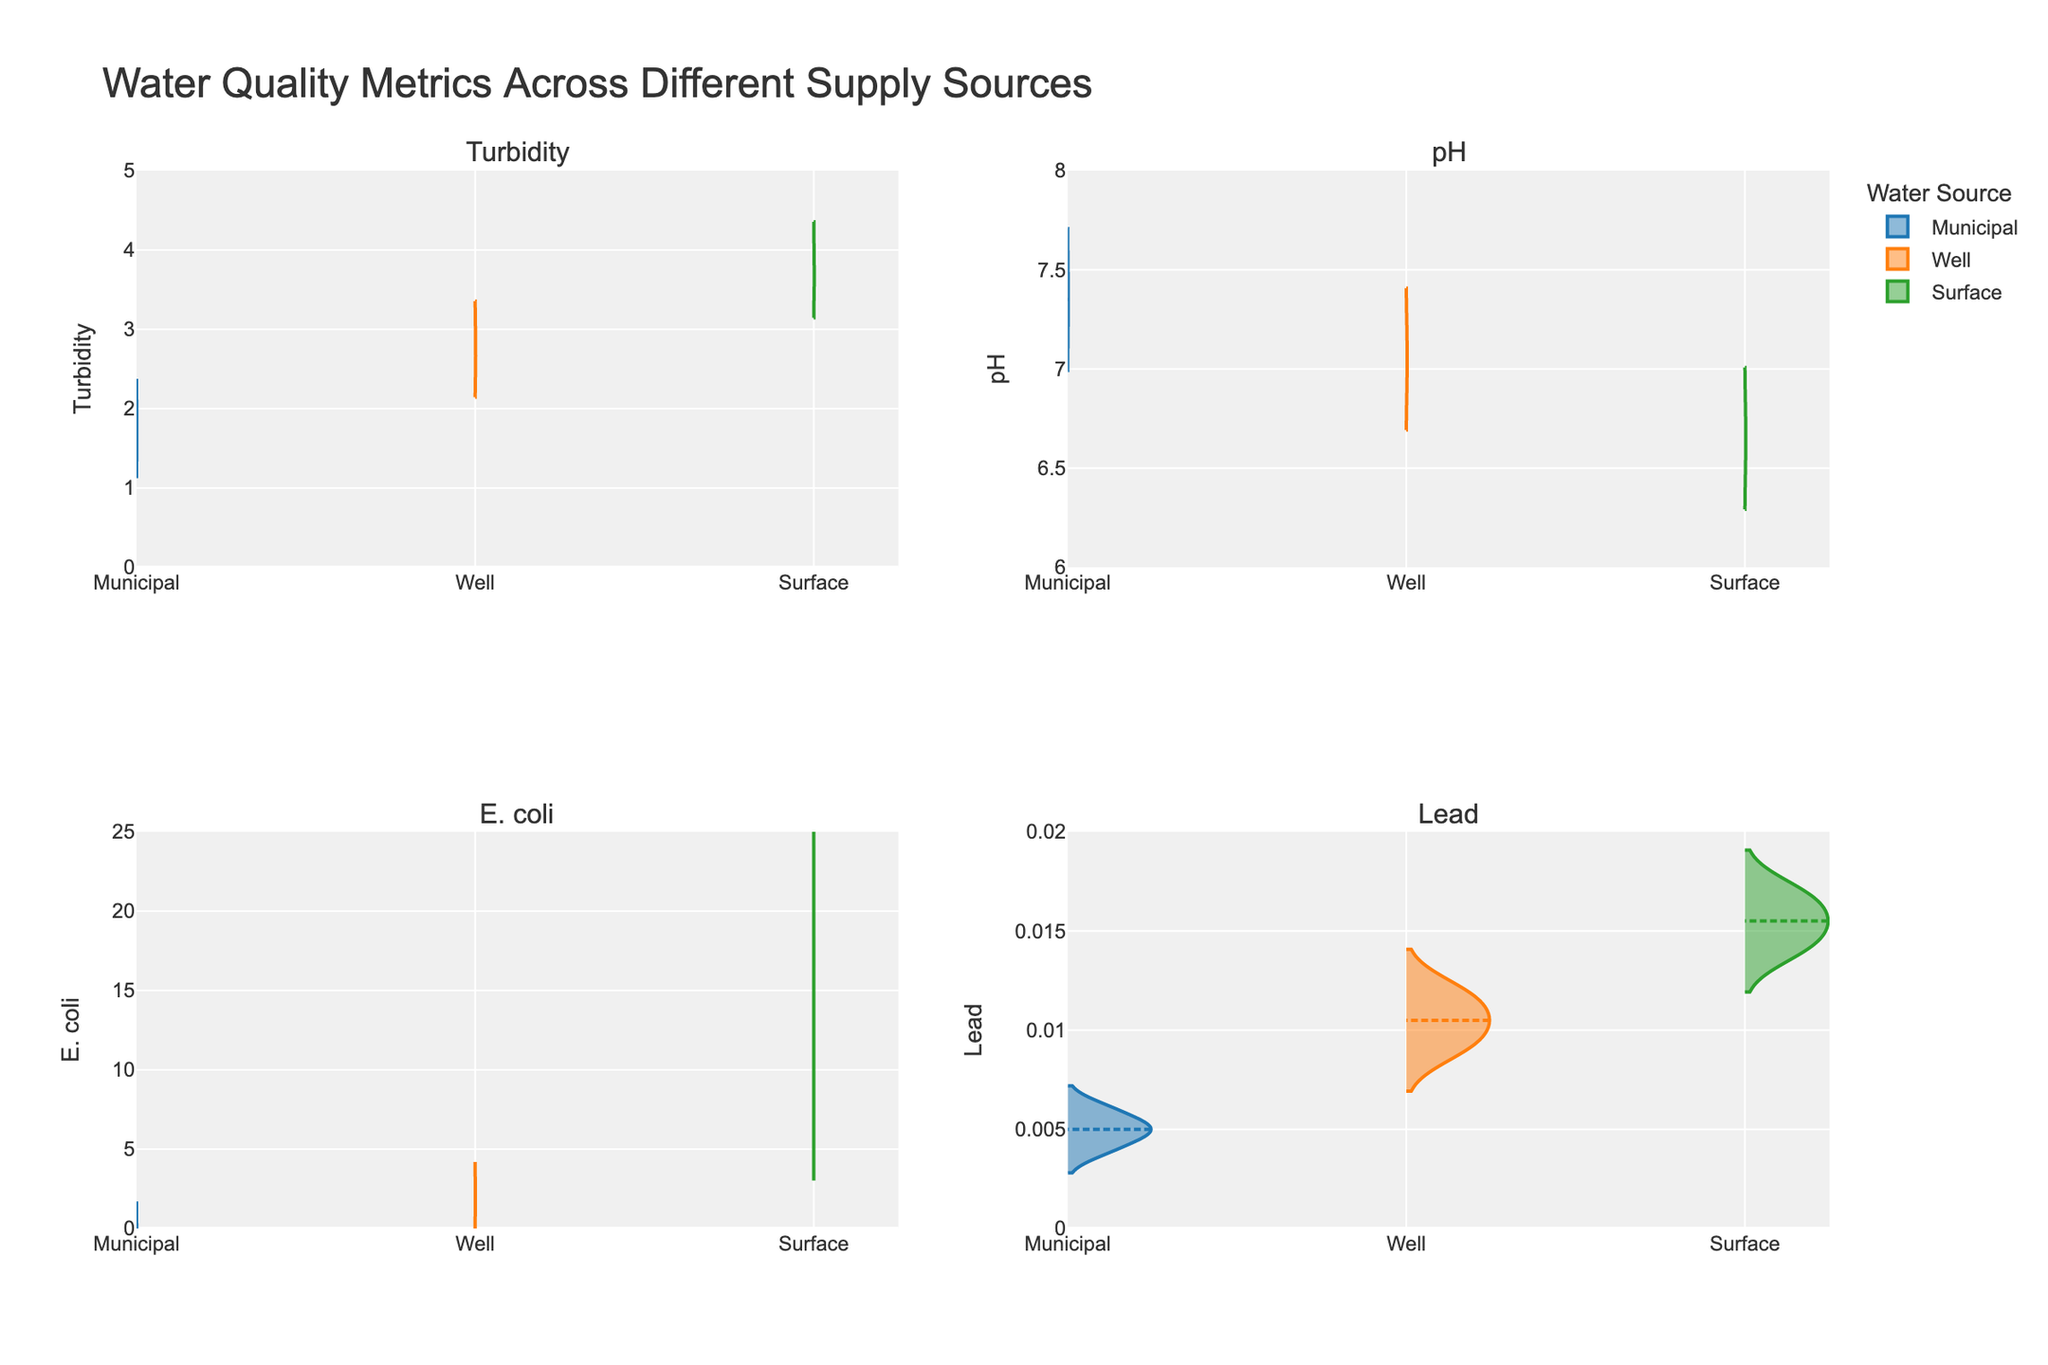What is the median turbidity value for the Municipal water source? Look at the violin plot for the Municipal water source in the Turbidity subplot. The values shown are 1.5, 1.8, 2.0, and 1.6. The median lies between the middle values 1.6 and 1.8, which is (1.6 + 1.8)/2 = 1.7.
Answer: 1.7 Which water source has the highest average pH? Compare the mean lines on the violin plots for pH. The Municipal source ranges around 7.3 to 7.4, the Well source around 7.05, and the Surface source around 6.65. The Municipal source has the highest average pH.
Answer: Municipal How many subplots are presented in the figure? The figure is divided into a 2x2 grid, consisting of 4 subplots.
Answer: 4 Which water source has the higher spread of E. coli values? Observe the range of E. coli values in the violin plots for each water source. Municipal ranges from 0 to 1, Well from 1 to 3, and Surface from 10 to 20. Surface has the highest spread.
Answer: Surface What is the range of Lead levels in the Well water source? The violin plot for Lead in the Well water source ranges from 0.009 to 0.012.
Answer: 0.009 to 0.012 Which parameter shows the largest difference in maximum values between the Well and Surface water sources? Look at the maximum values for each parameter in Well and Surface. Turbidity has 3.0 (Well) and 4.0 (Surface), pH has 7.2 (Well) and 6.8 (Surface), E. coli has 3 (Well) and 20 (Surface), and Lead has 0.012 (Well) and 0.017 (Surface). E. coli shows the largest difference (20 - 3 = 17).
Answer: E. coli Which parameter for the Municipal water source shows a mean value closer to 7? Examine the mean lines on the violin plots for the Municipal water source. Turbidity is around 1.725, pH is around 7.35, E. coli is close to 0, and Lead is around 0.005. pH is closest to 7.
Answer: pH Which water source has the lowest minimum value for the E. coli parameter? Check the lower ends of the violin plots for E. coli. Municipal, Well, and Surface start from 0, 1, and 10, respectively. Municipal has the lowest minimum value.
Answer: Municipal 